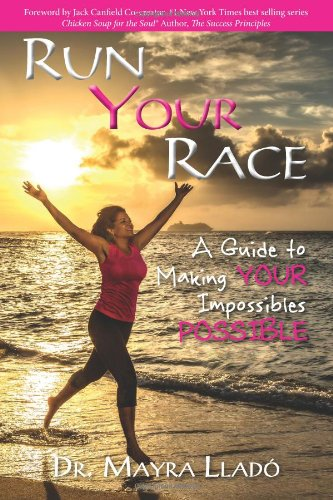What is the title of this book? The title of this inspiring book is 'Run Your Race: A Guide to Making Your Impossibles Possible,' which hints at a personal development journey geared towards enabling the reader to achieve their personal best. 